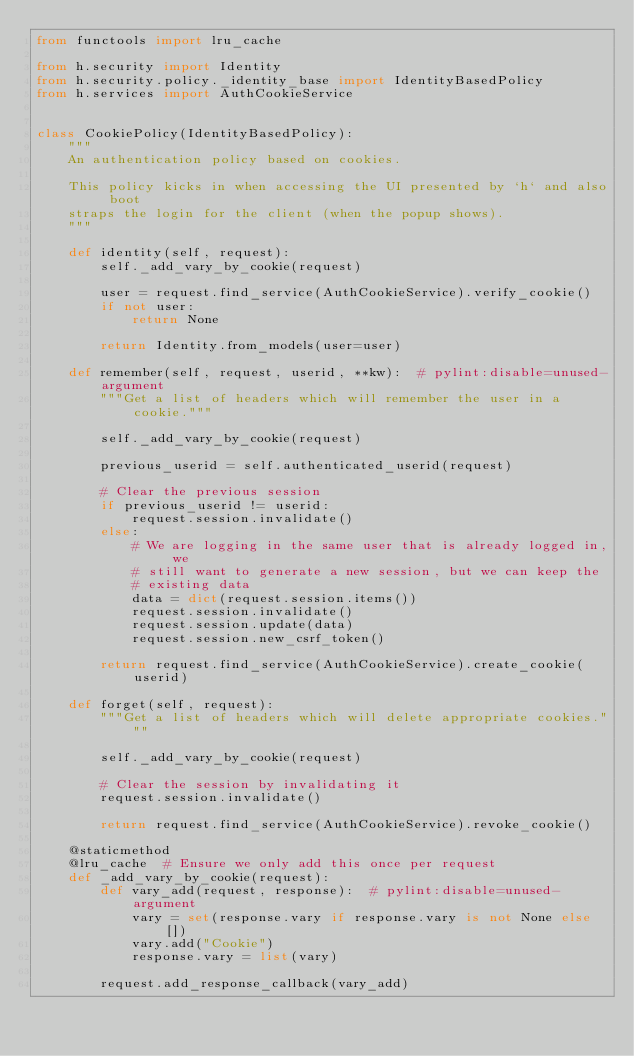<code> <loc_0><loc_0><loc_500><loc_500><_Python_>from functools import lru_cache

from h.security import Identity
from h.security.policy._identity_base import IdentityBasedPolicy
from h.services import AuthCookieService


class CookiePolicy(IdentityBasedPolicy):
    """
    An authentication policy based on cookies.

    This policy kicks in when accessing the UI presented by `h` and also boot
    straps the login for the client (when the popup shows).
    """

    def identity(self, request):
        self._add_vary_by_cookie(request)

        user = request.find_service(AuthCookieService).verify_cookie()
        if not user:
            return None

        return Identity.from_models(user=user)

    def remember(self, request, userid, **kw):  # pylint:disable=unused-argument
        """Get a list of headers which will remember the user in a cookie."""

        self._add_vary_by_cookie(request)

        previous_userid = self.authenticated_userid(request)

        # Clear the previous session
        if previous_userid != userid:
            request.session.invalidate()
        else:
            # We are logging in the same user that is already logged in, we
            # still want to generate a new session, but we can keep the
            # existing data
            data = dict(request.session.items())
            request.session.invalidate()
            request.session.update(data)
            request.session.new_csrf_token()

        return request.find_service(AuthCookieService).create_cookie(userid)

    def forget(self, request):
        """Get a list of headers which will delete appropriate cookies."""

        self._add_vary_by_cookie(request)

        # Clear the session by invalidating it
        request.session.invalidate()

        return request.find_service(AuthCookieService).revoke_cookie()

    @staticmethod
    @lru_cache  # Ensure we only add this once per request
    def _add_vary_by_cookie(request):
        def vary_add(request, response):  # pylint:disable=unused-argument
            vary = set(response.vary if response.vary is not None else [])
            vary.add("Cookie")
            response.vary = list(vary)

        request.add_response_callback(vary_add)
</code> 